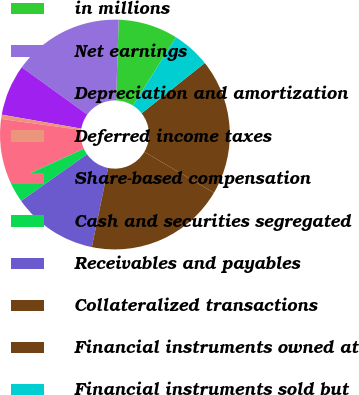Convert chart to OTSL. <chart><loc_0><loc_0><loc_500><loc_500><pie_chart><fcel>in millions<fcel>Net earnings<fcel>Depreciation and amortization<fcel>Deferred income taxes<fcel>Share-based compensation<fcel>Cash and securities segregated<fcel>Receivables and payables<fcel>Collateralized transactions<fcel>Financial instruments owned at<fcel>Financial instruments sold but<nl><fcel>8.38%<fcel>15.57%<fcel>7.19%<fcel>0.6%<fcel>8.98%<fcel>2.99%<fcel>11.98%<fcel>19.76%<fcel>19.16%<fcel>5.39%<nl></chart> 